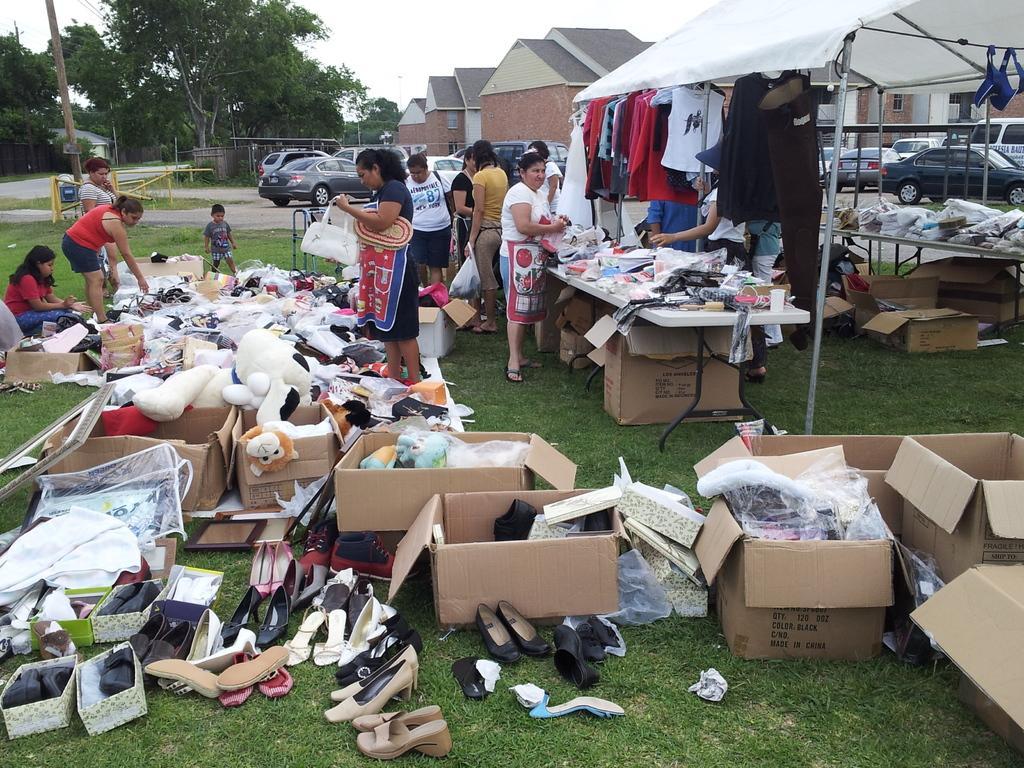Can you describe this image briefly? Here we can see group of people standing near a tent which is having all clothes,toys,shoes at the back we can see cars,houses and trees and the sky is clear 